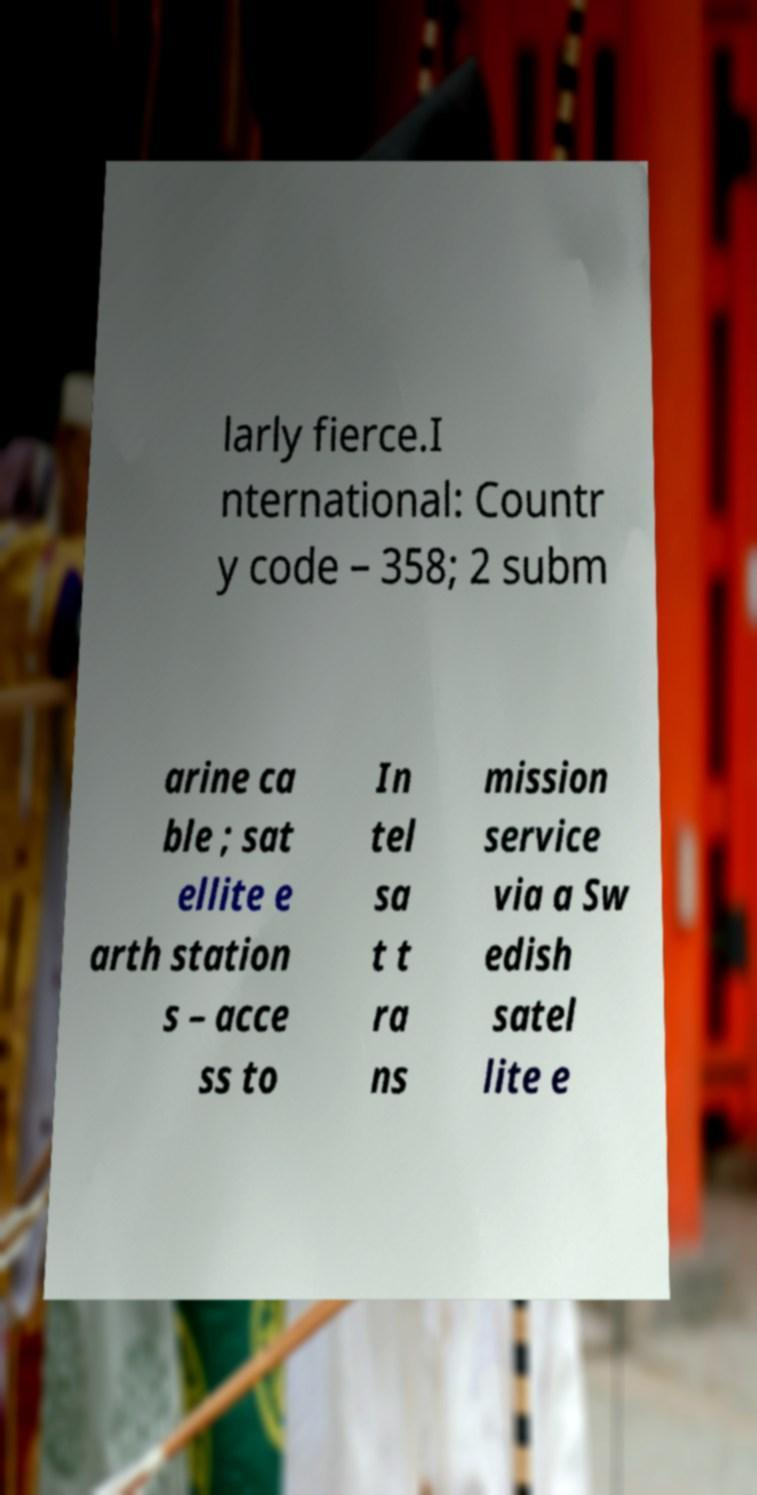For documentation purposes, I need the text within this image transcribed. Could you provide that? larly fierce.I nternational: Countr y code – 358; 2 subm arine ca ble ; sat ellite e arth station s – acce ss to In tel sa t t ra ns mission service via a Sw edish satel lite e 